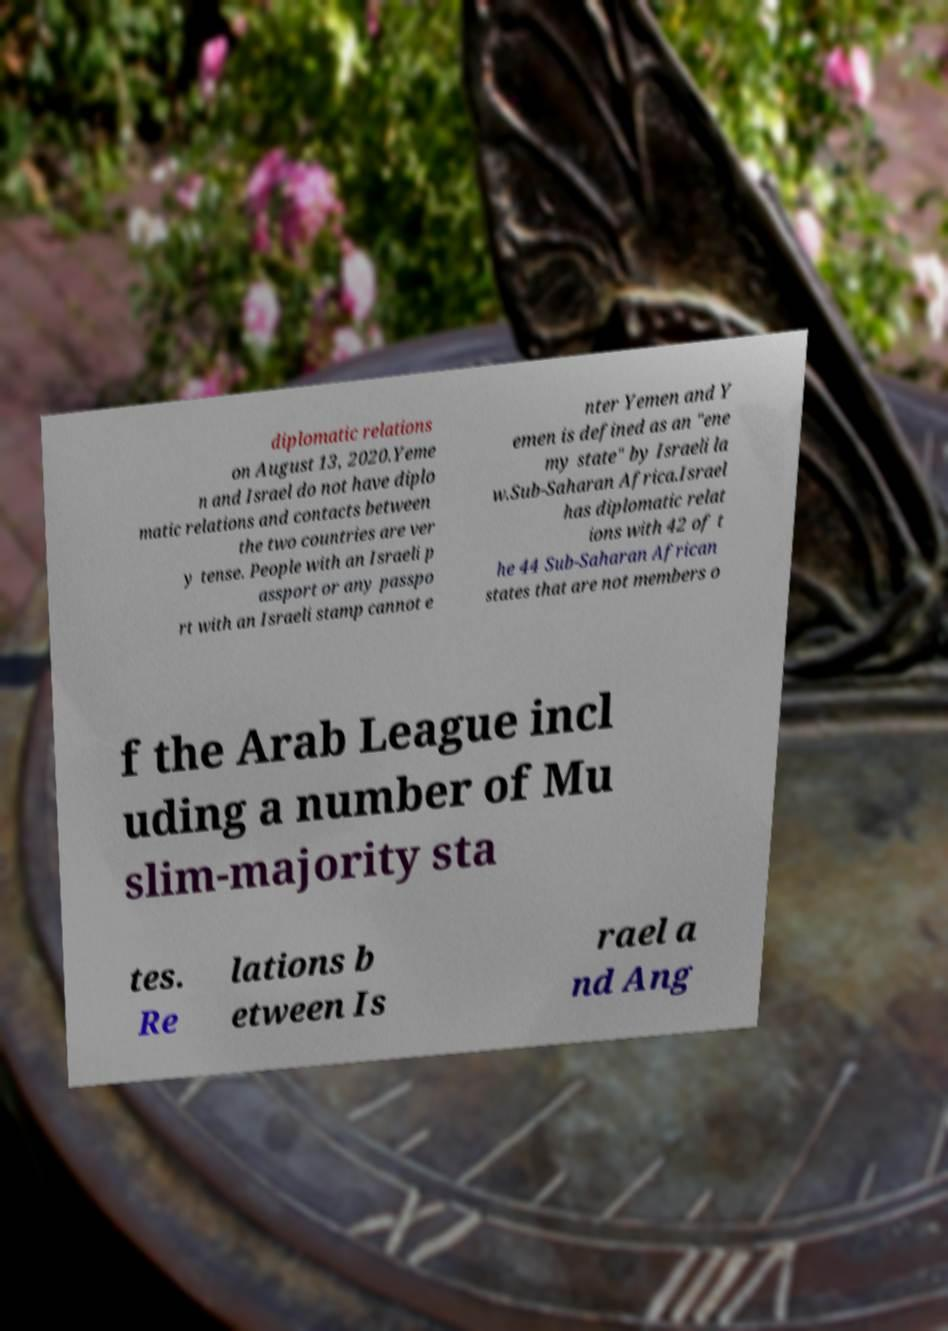Please identify and transcribe the text found in this image. diplomatic relations on August 13, 2020.Yeme n and Israel do not have diplo matic relations and contacts between the two countries are ver y tense. People with an Israeli p assport or any passpo rt with an Israeli stamp cannot e nter Yemen and Y emen is defined as an "ene my state" by Israeli la w.Sub-Saharan Africa.Israel has diplomatic relat ions with 42 of t he 44 Sub-Saharan African states that are not members o f the Arab League incl uding a number of Mu slim-majority sta tes. Re lations b etween Is rael a nd Ang 